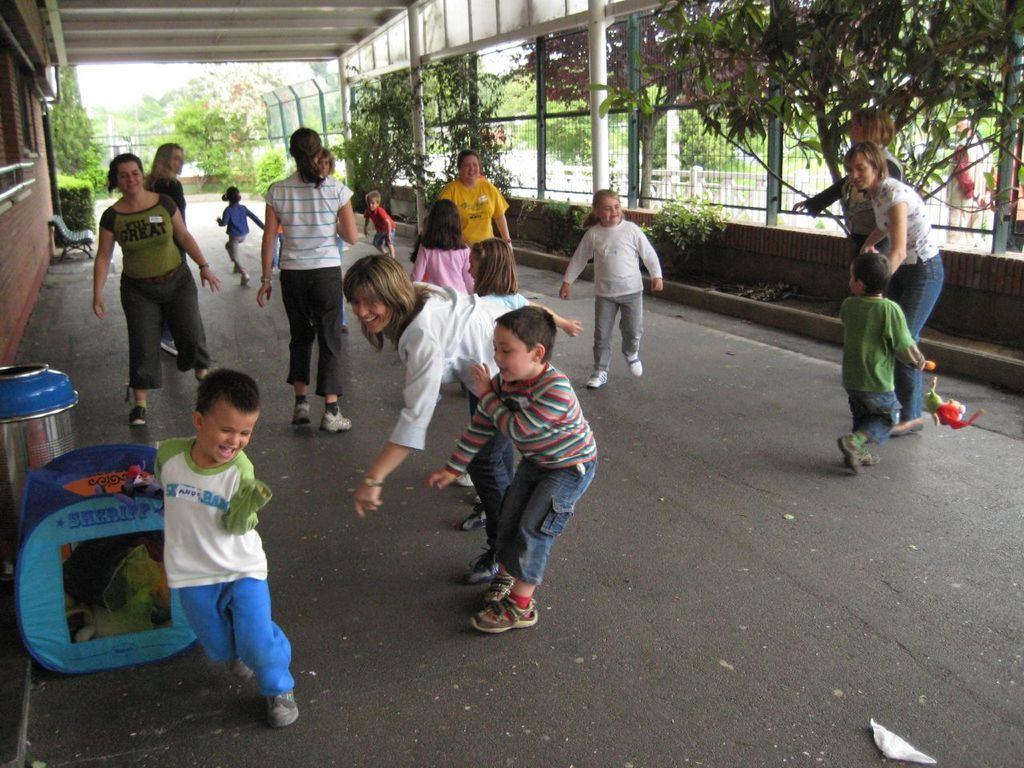Please provide a concise description of this image. In this picture we can see some people standing, on the left side there is a house, in the background we can see some plants and trees, on the right side there are grilles and plants, on the left side there is a bench and a dustbin. 